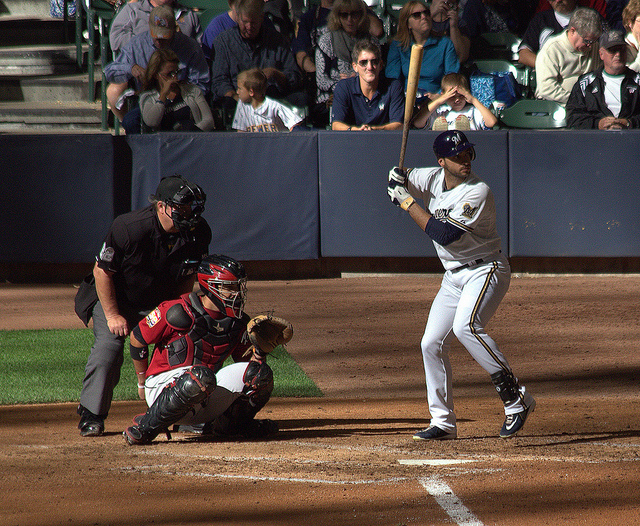Read all the text in this image. M 